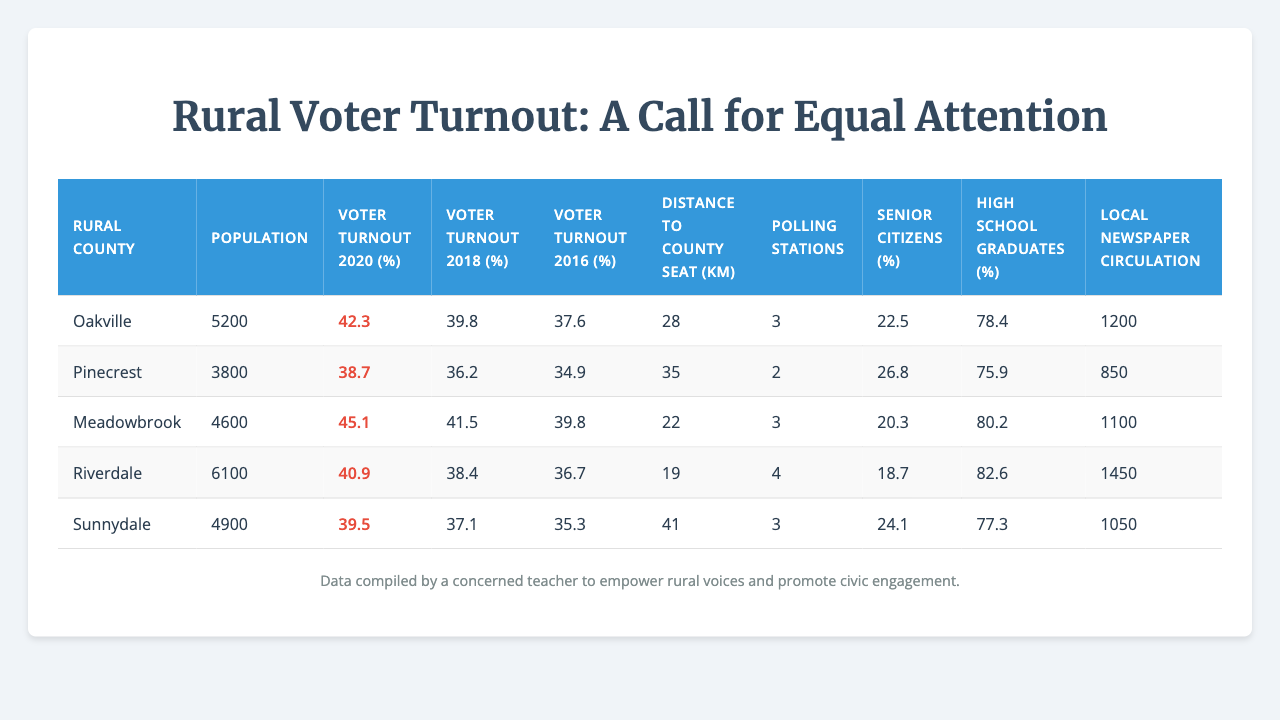What is the voter turnout percentage in Oakville for the year 2020? The table shows that the voter turnout in Oakville for the year 2020 is 42.3%.
Answer: 42.3% Which rural county has the highest voter turnout in 2020? By comparing the voter turnout percentages from the table, Riverdale has the highest voter turnout in 2020 at 40.9%.
Answer: Riverdale What is the average voter turnout in 2018 for the listed rural counties? The voter turnout percentages for 2018 are 38.7, 36.2, 41.5, 38.4, and 37.1. The sum is 191.9, and there are 5 counties, so the average is 191.9 / 5 = 38.38%.
Answer: 38.38% How many polling stations are there in Sunnydale? The table indicates that Sunnydale has 3 polling stations.
Answer: 3 Is the voter turnout in Meadowbrook higher in 2020 than in 2016? The voter turnout for Meadowbrook in 2020 is 45.1% and in 2016 it is 39.8%. Since 45.1% is greater than 39.8%, the statement is true.
Answer: Yes What is the difference in voter turnout between Pinecrest in 2020 and 2018? The voter turnout in Pinecrest for 2020 is 38.7% and for 2018 is 36.2%. The difference is 38.7% - 36.2% = 2.5%.
Answer: 2.5% Which county has the lowest percentage of high school graduates? The table shows that Pinecrest has the lowest percentage of high school graduates at 75.9%.
Answer: Pinecrest What is the total population of the listed rural counties? The populations are 5200 (Oakville), 3800 (Pinecrest), 4600 (Meadowbrook), 6100 (Riverdale), and 4900 (Sunnydale). The total population is 5200 + 3800 + 4600 + 6100 + 4900 = 24600.
Answer: 24600 Are there more senior citizens in Riverdale than in Sunnydale? Riverdale has 18.7% of senior citizens while Sunnydale has 24.1%. Since 24.1% is greater than 18.7%, the statement is false.
Answer: No What is the median voter turnout for the year 2020 among these counties? The voter turnout for 2020 is 42.3, 38.7, 45.1, 40.9, and 39.5. When arranged in order, the middle value (median) is 40.9%.
Answer: 40.9% How does the number of polling stations correlate with voter turnout in 2020? To analyze the correlation, we compare the number of polling stations to their respective turnout rates: Oakville (3: 42.3%), Pinecrest (2: 38.7%), Meadowbrook (3: 45.1%), Riverdale (4: 40.9%), Sunnydale (3: 39.5%). There doesn’t seem to be a clear correlation; however, Riverdale, with 4 stations, has a slightly lower turnout than Meadowbrook and Oakville which have 3.
Answer: No clear correlation 